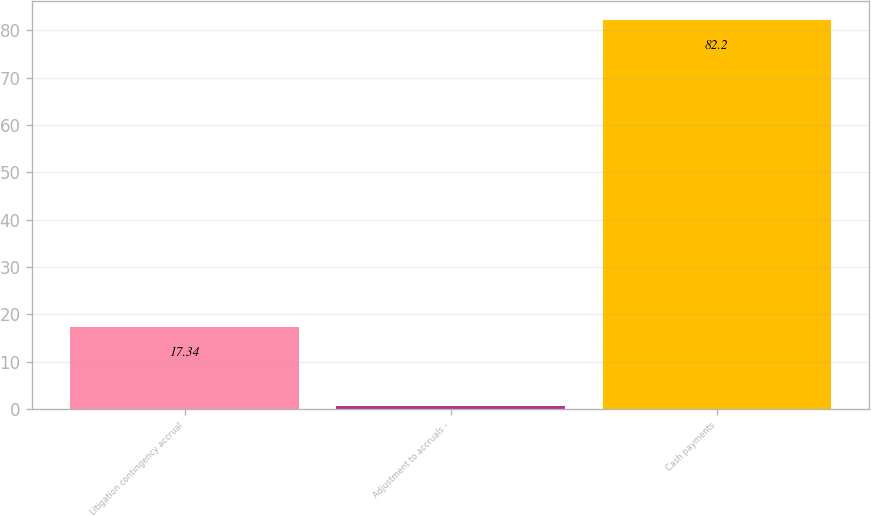<chart> <loc_0><loc_0><loc_500><loc_500><bar_chart><fcel>Litigation contingency accrual<fcel>Adjustment to accruals -<fcel>Cash payments<nl><fcel>17.34<fcel>0.7<fcel>82.2<nl></chart> 